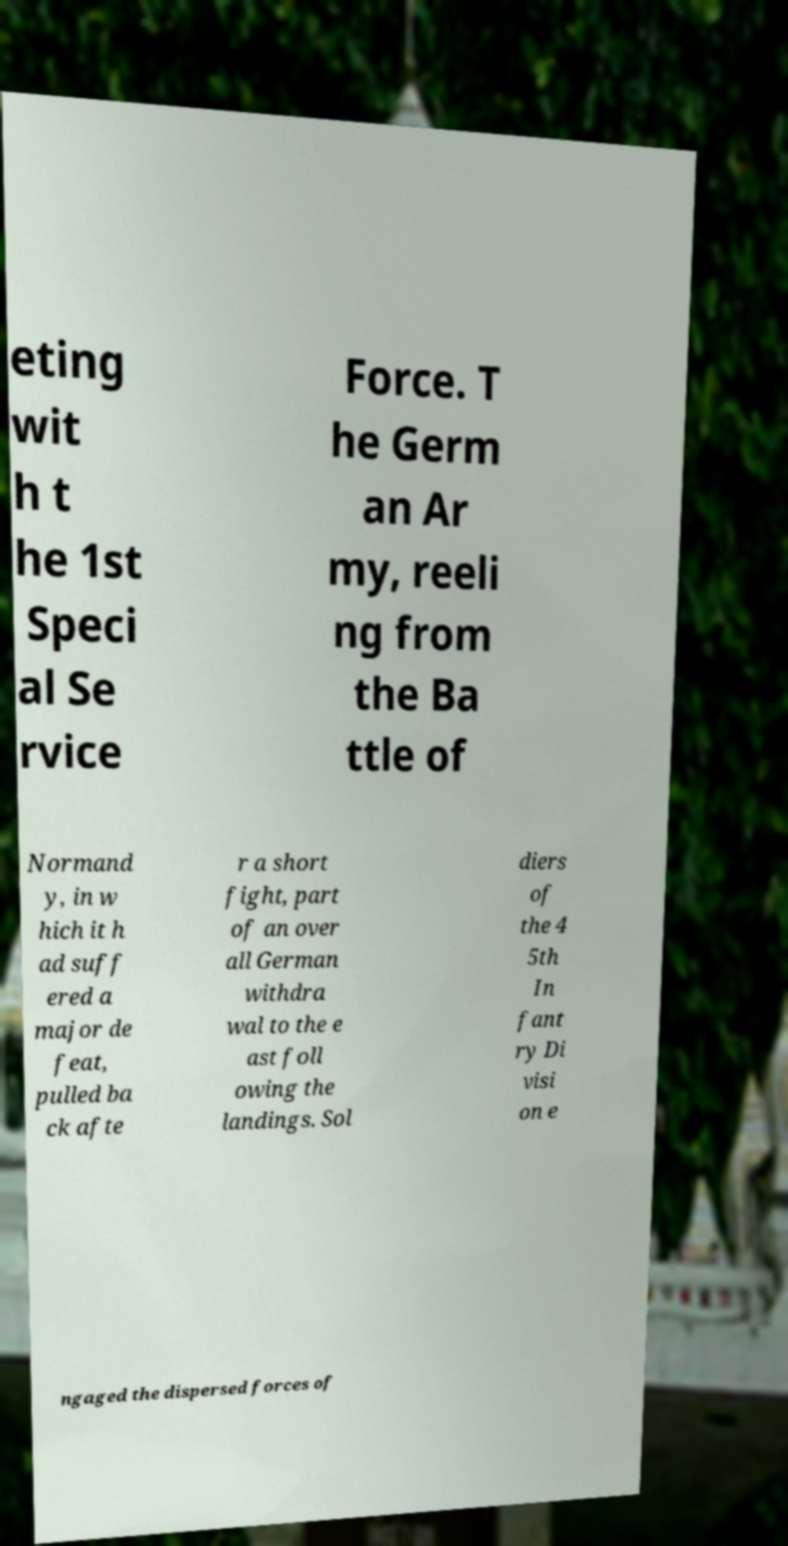There's text embedded in this image that I need extracted. Can you transcribe it verbatim? eting wit h t he 1st Speci al Se rvice Force. T he Germ an Ar my, reeli ng from the Ba ttle of Normand y, in w hich it h ad suff ered a major de feat, pulled ba ck afte r a short fight, part of an over all German withdra wal to the e ast foll owing the landings. Sol diers of the 4 5th In fant ry Di visi on e ngaged the dispersed forces of 